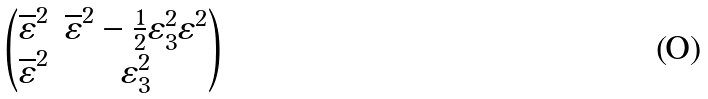Convert formula to latex. <formula><loc_0><loc_0><loc_500><loc_500>\begin{pmatrix} \overline { \varepsilon } ^ { 2 } & \overline { \varepsilon } ^ { 2 } - \frac { 1 } { 2 } \varepsilon ^ { 2 } _ { 3 } \varepsilon ^ { 2 } \\ \overline { \varepsilon } ^ { 2 } & \varepsilon _ { 3 } ^ { 2 } \end{pmatrix}</formula> 